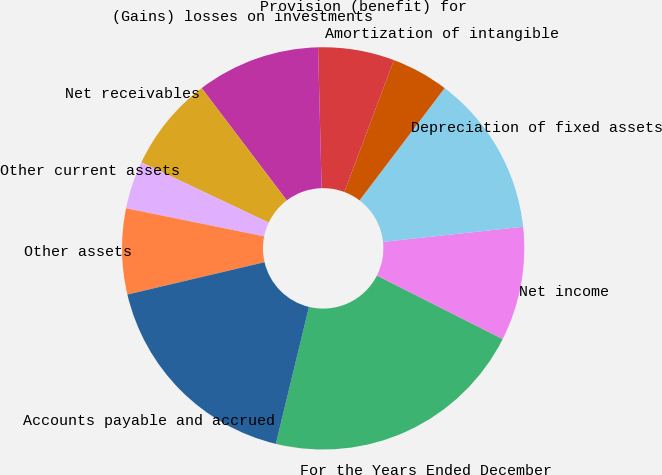Convert chart. <chart><loc_0><loc_0><loc_500><loc_500><pie_chart><fcel>For the Years Ended December<fcel>Net income<fcel>Depreciation of fixed assets<fcel>Amortization of intangible<fcel>Provision (benefit) for<fcel>(Gains) losses on investments<fcel>Net receivables<fcel>Other current assets<fcel>Other assets<fcel>Accounts payable and accrued<nl><fcel>21.33%<fcel>9.16%<fcel>12.96%<fcel>4.6%<fcel>6.12%<fcel>9.92%<fcel>7.64%<fcel>3.84%<fcel>6.88%<fcel>17.53%<nl></chart> 